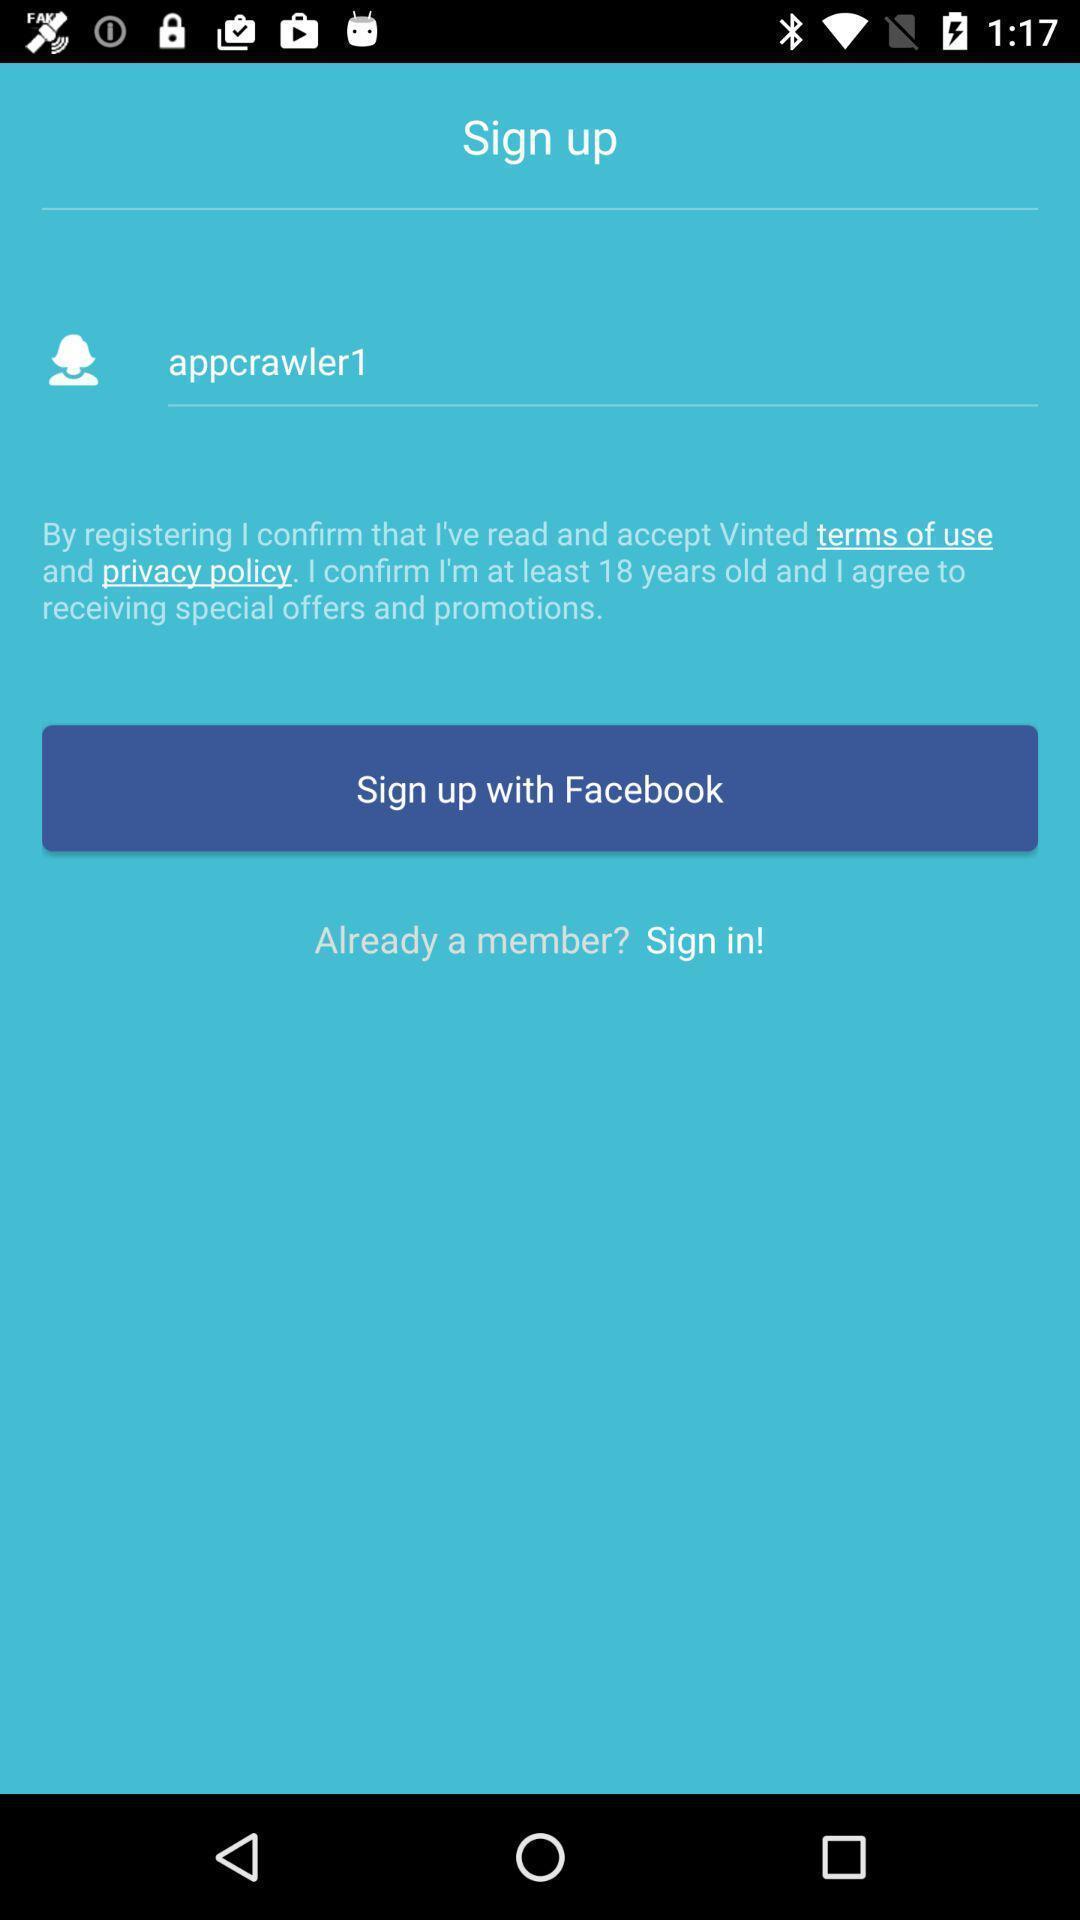Explain what's happening in this screen capture. Sign up page for an application. 